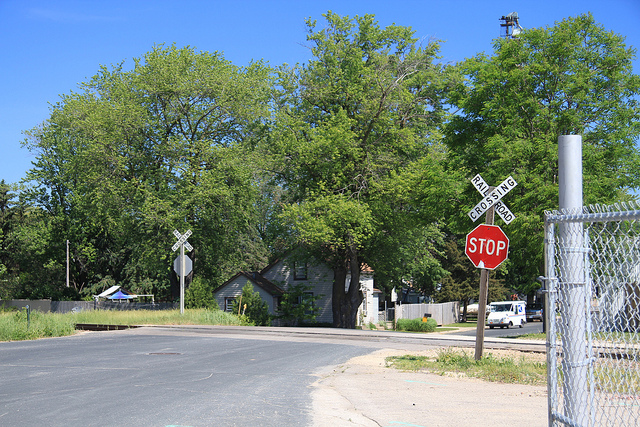Read and extract the text from this image. RAILROAD CROSSING STOP 